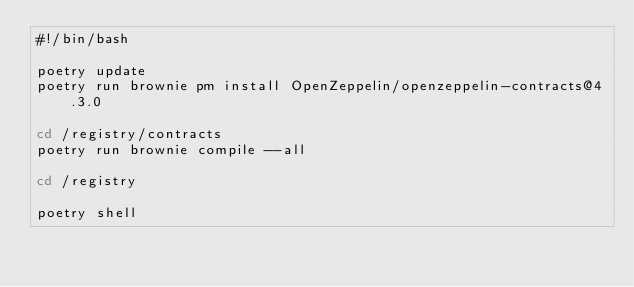<code> <loc_0><loc_0><loc_500><loc_500><_Bash_>#!/bin/bash

poetry update
poetry run brownie pm install OpenZeppelin/openzeppelin-contracts@4.3.0

cd /registry/contracts
poetry run brownie compile --all

cd /registry

poetry shell
</code> 